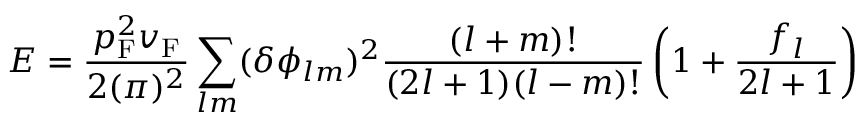<formula> <loc_0><loc_0><loc_500><loc_500>E = { \frac { p _ { F } ^ { 2 } v _ { F } } { 2 ( \pi ) ^ { 2 } } } \sum _ { l m } ( \delta \phi _ { l m } ) ^ { 2 } { \frac { ( l + m ) ! } { ( 2 l + 1 ) ( l - m ) ! } } \left ( 1 + { \frac { f _ { l } } { 2 l + 1 } } \right )</formula> 